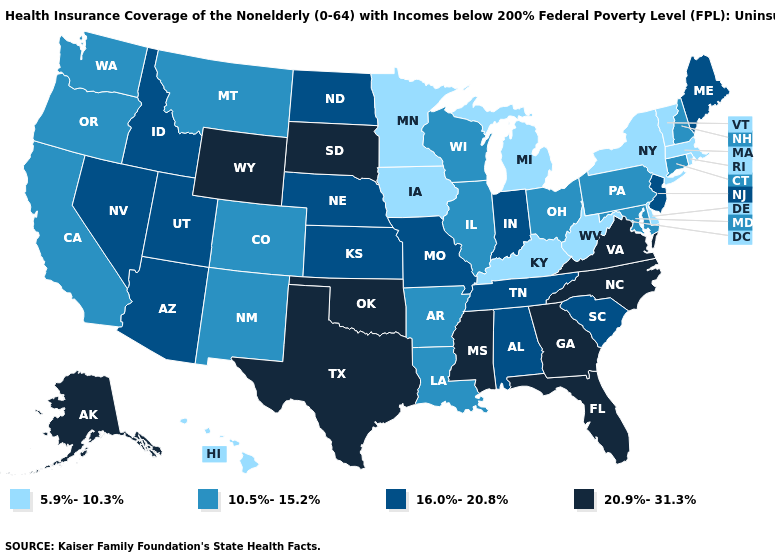Does Hawaii have the highest value in the West?
Short answer required. No. What is the value of Illinois?
Give a very brief answer. 10.5%-15.2%. Which states hav the highest value in the West?
Short answer required. Alaska, Wyoming. What is the lowest value in states that border Florida?
Keep it brief. 16.0%-20.8%. Name the states that have a value in the range 20.9%-31.3%?
Answer briefly. Alaska, Florida, Georgia, Mississippi, North Carolina, Oklahoma, South Dakota, Texas, Virginia, Wyoming. Name the states that have a value in the range 10.5%-15.2%?
Quick response, please. Arkansas, California, Colorado, Connecticut, Illinois, Louisiana, Maryland, Montana, New Hampshire, New Mexico, Ohio, Oregon, Pennsylvania, Washington, Wisconsin. Is the legend a continuous bar?
Write a very short answer. No. What is the value of Delaware?
Quick response, please. 5.9%-10.3%. What is the value of Vermont?
Quick response, please. 5.9%-10.3%. What is the value of New Jersey?
Keep it brief. 16.0%-20.8%. What is the value of Washington?
Keep it brief. 10.5%-15.2%. Does Oregon have a higher value than Minnesota?
Short answer required. Yes. Name the states that have a value in the range 10.5%-15.2%?
Answer briefly. Arkansas, California, Colorado, Connecticut, Illinois, Louisiana, Maryland, Montana, New Hampshire, New Mexico, Ohio, Oregon, Pennsylvania, Washington, Wisconsin. Which states have the lowest value in the MidWest?
Give a very brief answer. Iowa, Michigan, Minnesota. 